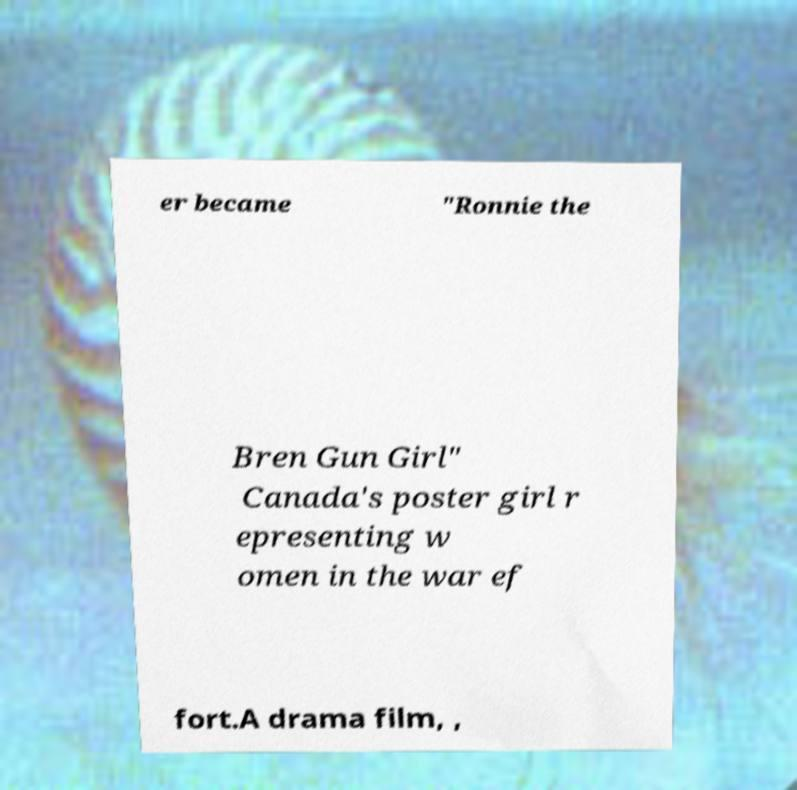Please read and relay the text visible in this image. What does it say? er became "Ronnie the Bren Gun Girl" Canada's poster girl r epresenting w omen in the war ef fort.A drama film, , 